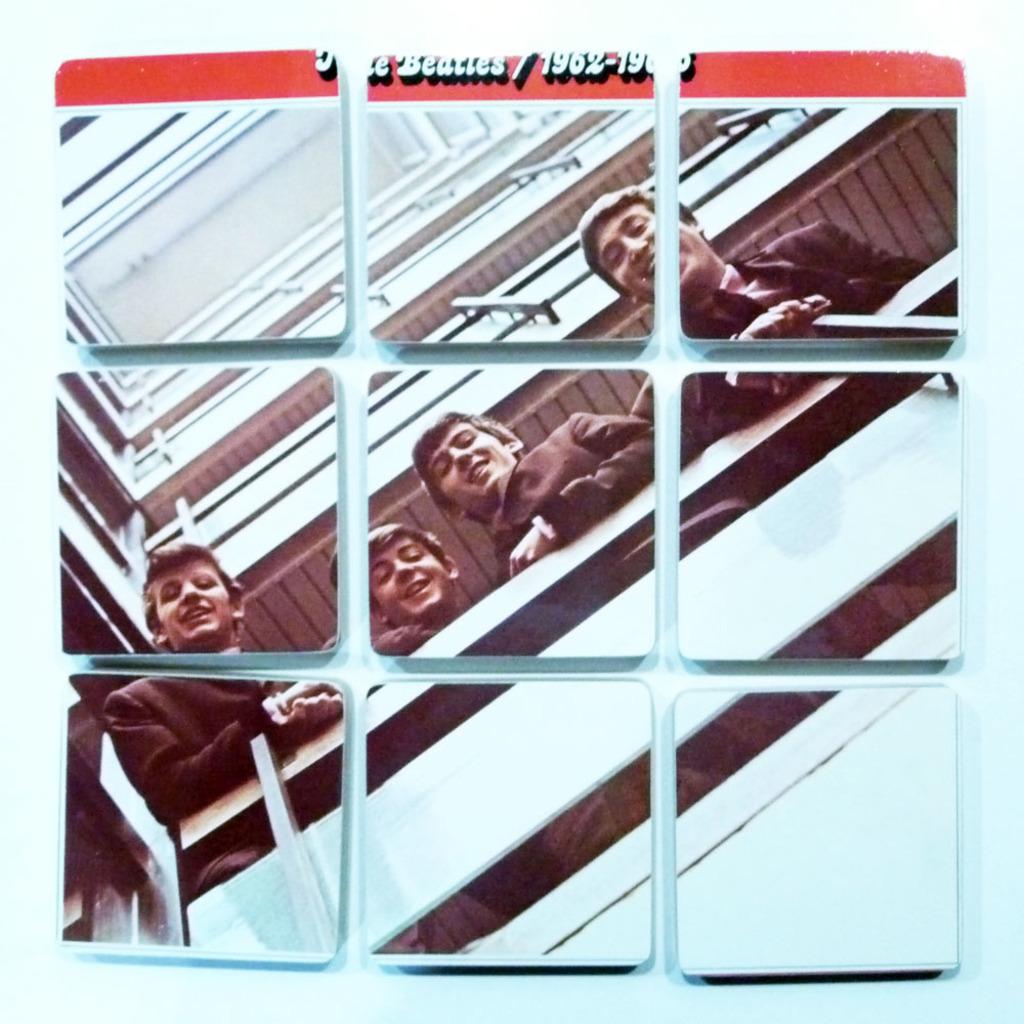How would you summarize this image in a sentence or two? There is a glass window. Through that we can see four people standing. Also there is a building. At the top something is written. 